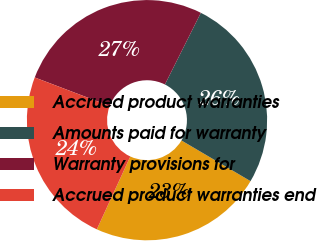Convert chart. <chart><loc_0><loc_0><loc_500><loc_500><pie_chart><fcel>Accrued product warranties<fcel>Amounts paid for warranty<fcel>Warranty provisions for<fcel>Accrued product warranties end<nl><fcel>23.39%<fcel>26.07%<fcel>26.61%<fcel>23.93%<nl></chart> 